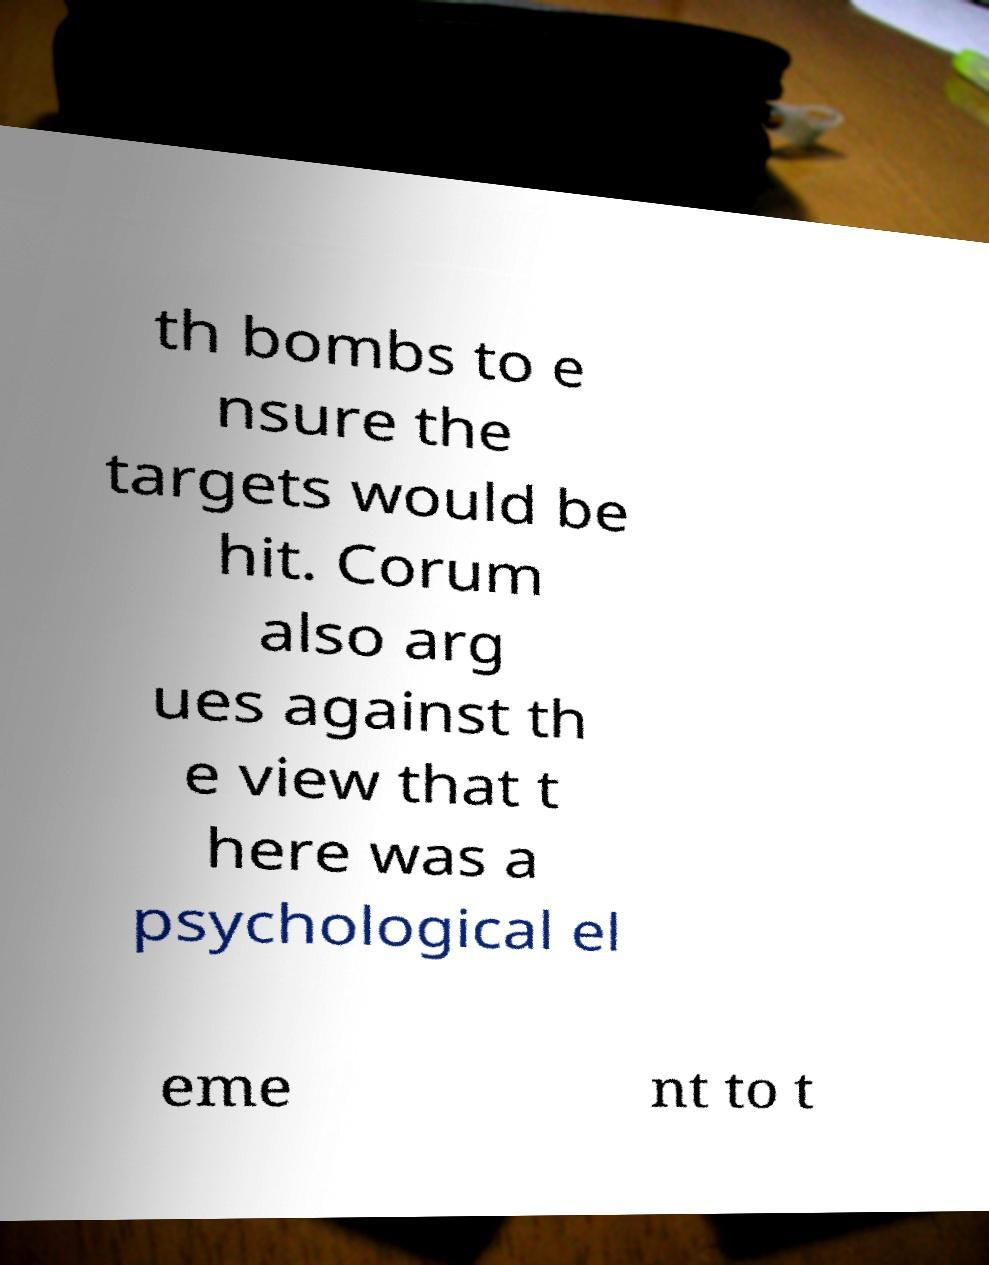Could you assist in decoding the text presented in this image and type it out clearly? th bombs to e nsure the targets would be hit. Corum also arg ues against th e view that t here was a psychological el eme nt to t 